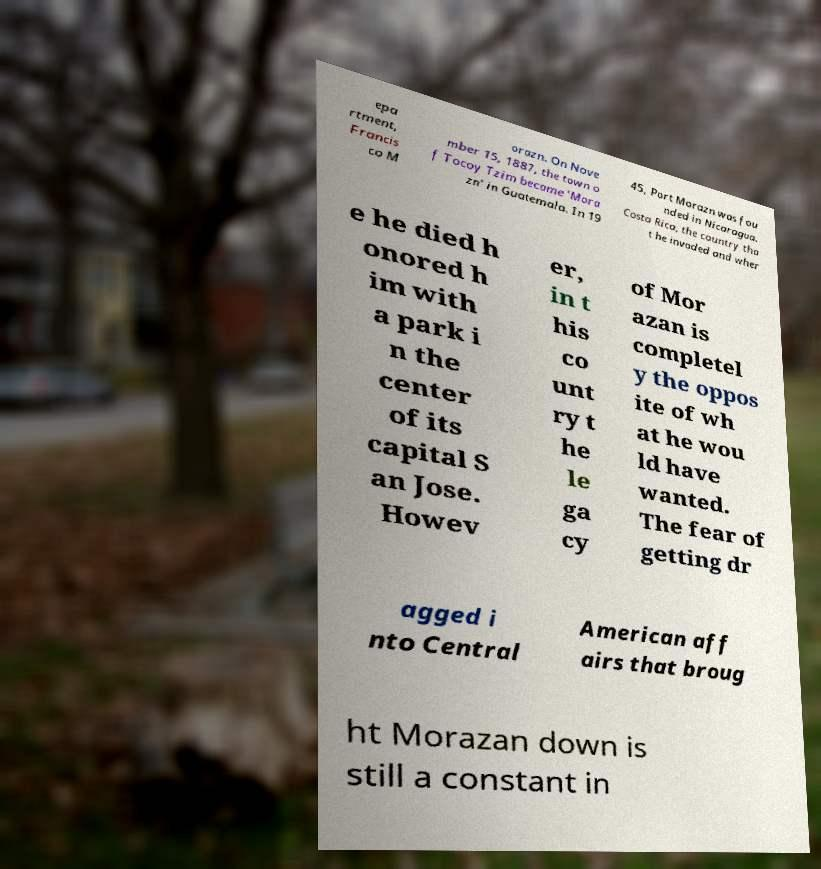There's text embedded in this image that I need extracted. Can you transcribe it verbatim? epa rtment, Francis co M orazn. On Nove mber 15, 1887, the town o f Tocoy Tzim became 'Mora zn' in Guatemala. In 19 45, Port Morazn was fou nded in Nicaragua. Costa Rica, the country tha t he invaded and wher e he died h onored h im with a park i n the center of its capital S an Jose. Howev er, in t his co unt ry t he le ga cy of Mor azan is completel y the oppos ite of wh at he wou ld have wanted. The fear of getting dr agged i nto Central American aff airs that broug ht Morazan down is still a constant in 